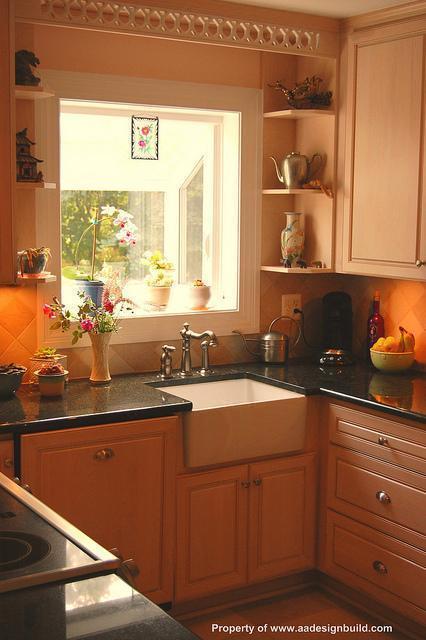What is the type of stove cooktop called?
Indicate the correct choice and explain in the format: 'Answer: answer
Rationale: rationale.'
Options: Induction, gas, electric, propane. Answer: electric.
Rationale: The stovetop is a flat surface meaning it runs on electricity. 